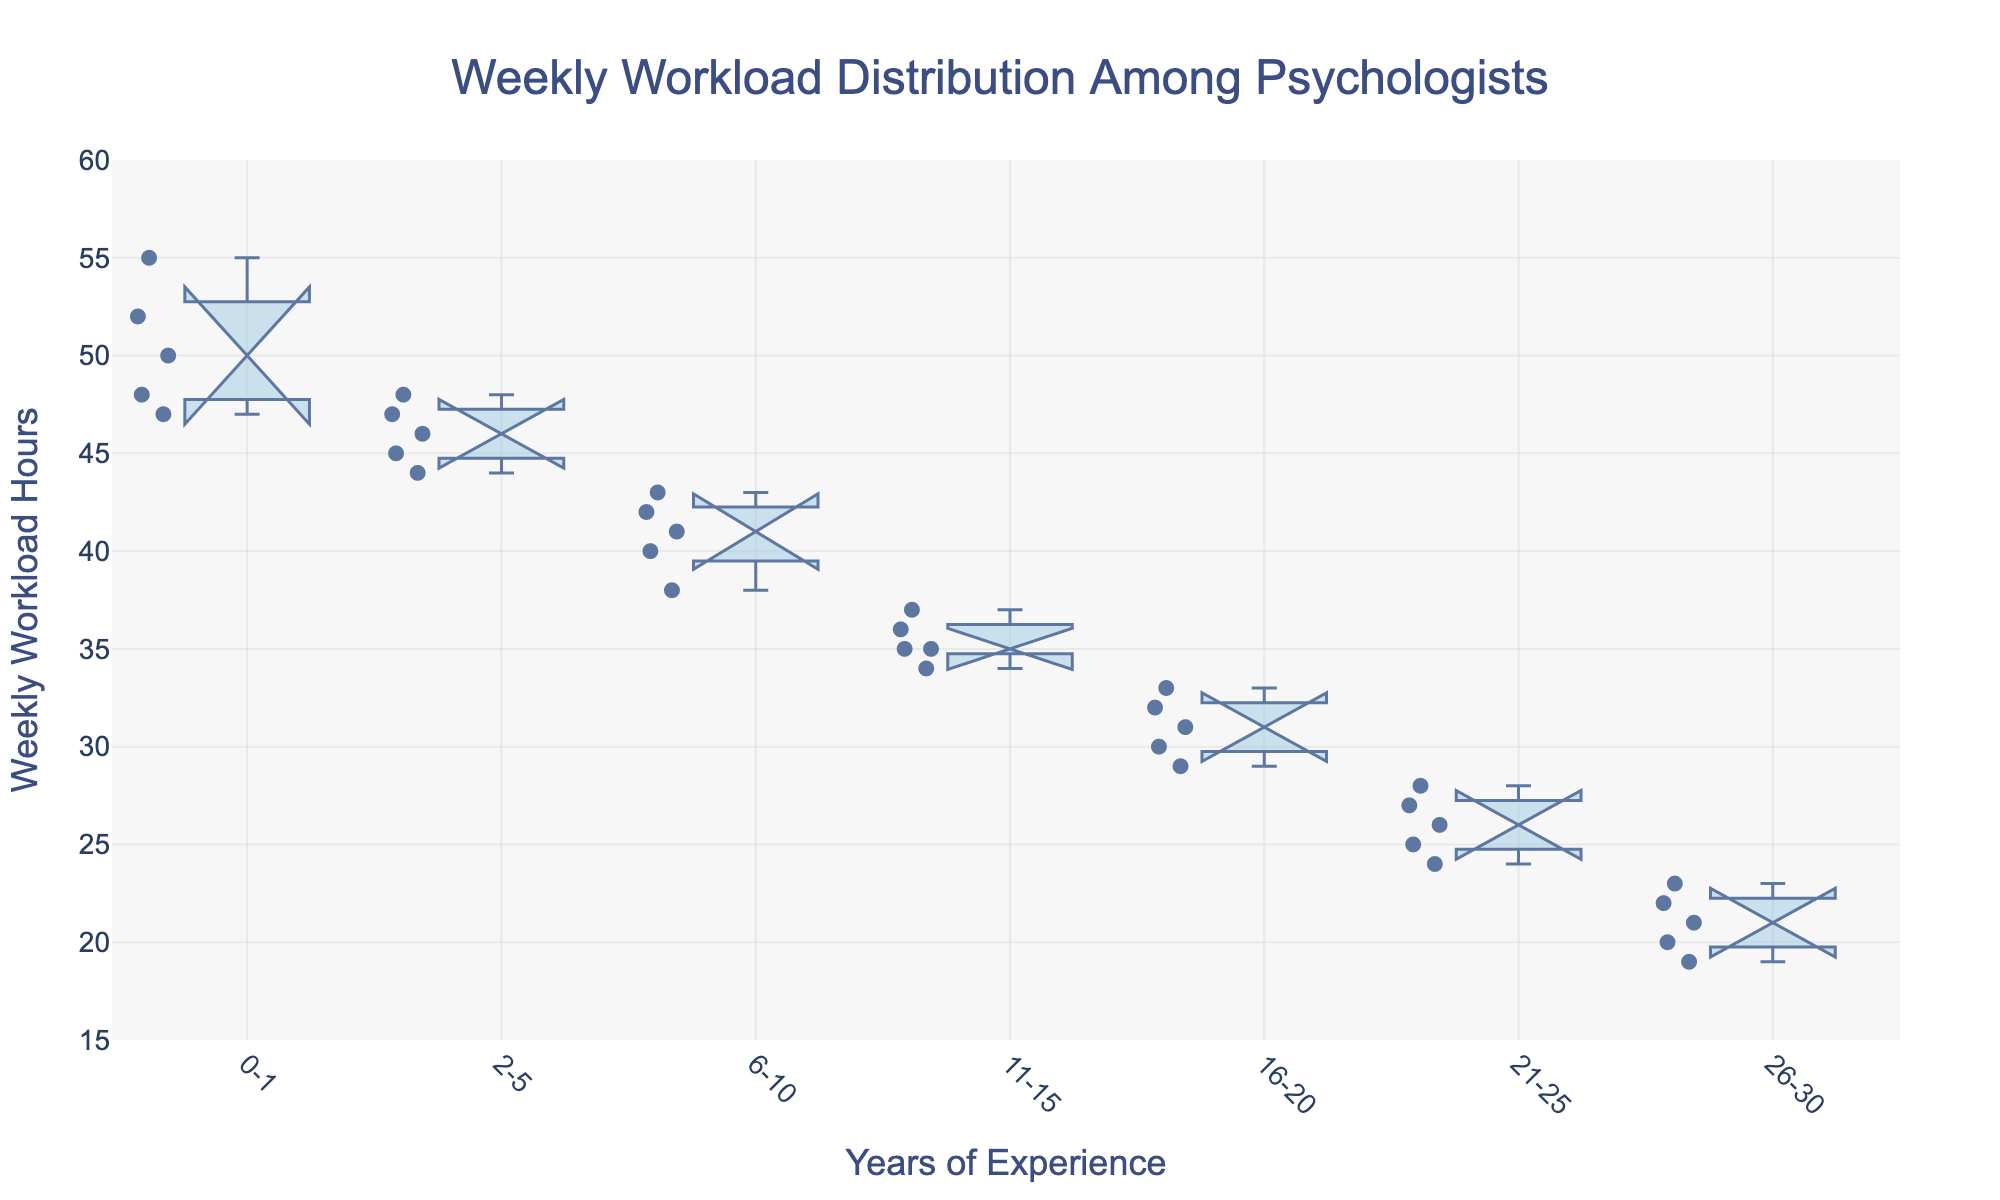What is the title of the plot? The title is displayed at the top center of the plot in a larger font size and more prominent color. It helps the viewer understand the main topic of the visualization.
Answer: Weekly Workload Distribution Among Psychologists How many categories of years of experience are there in the plot? The x-axis contains distinct labels representing different categories of years of experience. These labels need to be counted.
Answer: 7 Between which years of experience does the median weekly workload appear to be the highest? This involves finding the median line within each box plot and comparing their levels to identify the one that is the highest.
Answer: 0-1 What is the general trend observed in the weekly workload hours as years of experience increase? Observe how the central tendency (median) of the box plots shifts as the x-axis values (years of experience) increase.
Answer: Decreases What is the interquartile range (IQR) for psychologists with 2-5 years of experience? The IQR is the range between the first quartile (Q1) and the third quartile (Q3) in the box plot. Find these values from the box plot and subtract Q1 from Q3.
Answer: 3 (48 - 45) Which group has the smallest variability in weekly workload hours? Variability is indicated by the length of the box in the box plot. Find the group with the shortest box.
Answer: 16-20 Do any of the categories have overlapping notches? If so, which ones? Check the notched areas of each box plot to see if any notches overlap. Overlapping notches suggest that the medians are not significantly different.
Answer: Yes, 21-25 and 26-30 What is the approximate range of weekly workload hours for psychologists with 11-15 years of experience? The range is identified by the whiskers of the box plot. Find the minimum and maximum values for the given category.
Answer: 34 to 37 Which category has the widest notch? The width of the notch can be compared visually among all the categories to find which one is the widest.
Answer: 0-1 Is there any category where the lower quartile (Q1) is the same as the lowest observed value? If so, which one? This requires identifying a category where the bottom of the box (Q1) aligns with the bottom whisker.
Answer: 6-10 